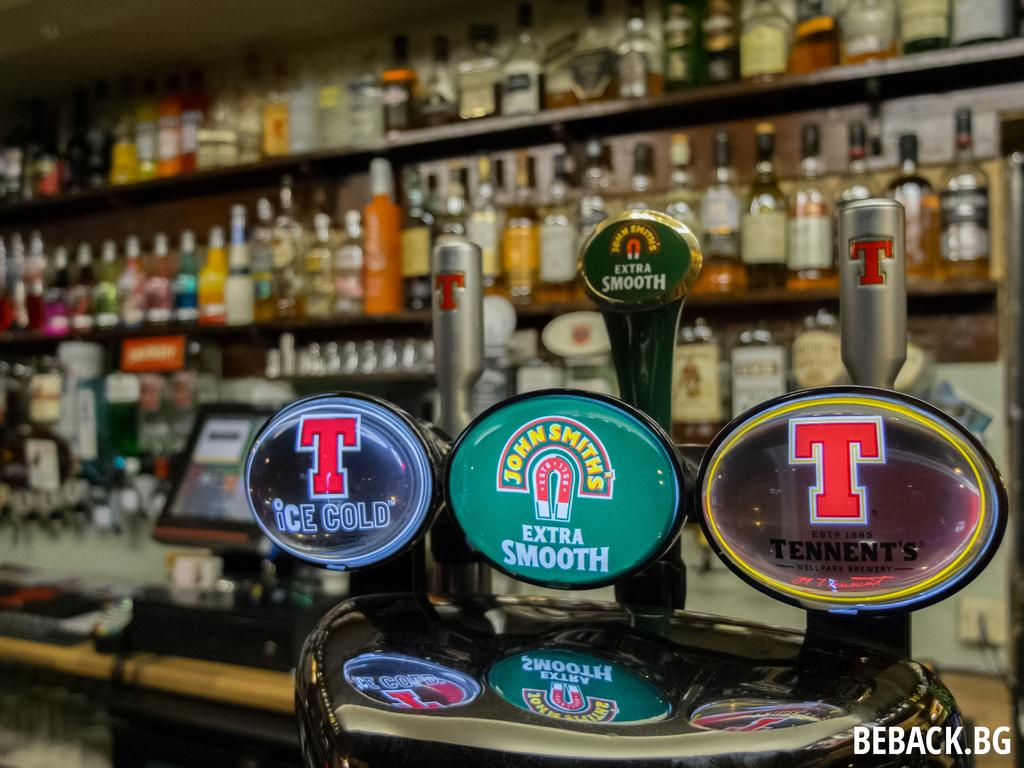<image>
Relay a brief, clear account of the picture shown. A bar has different bottles on the shelves and John Smith beer on the tap. 